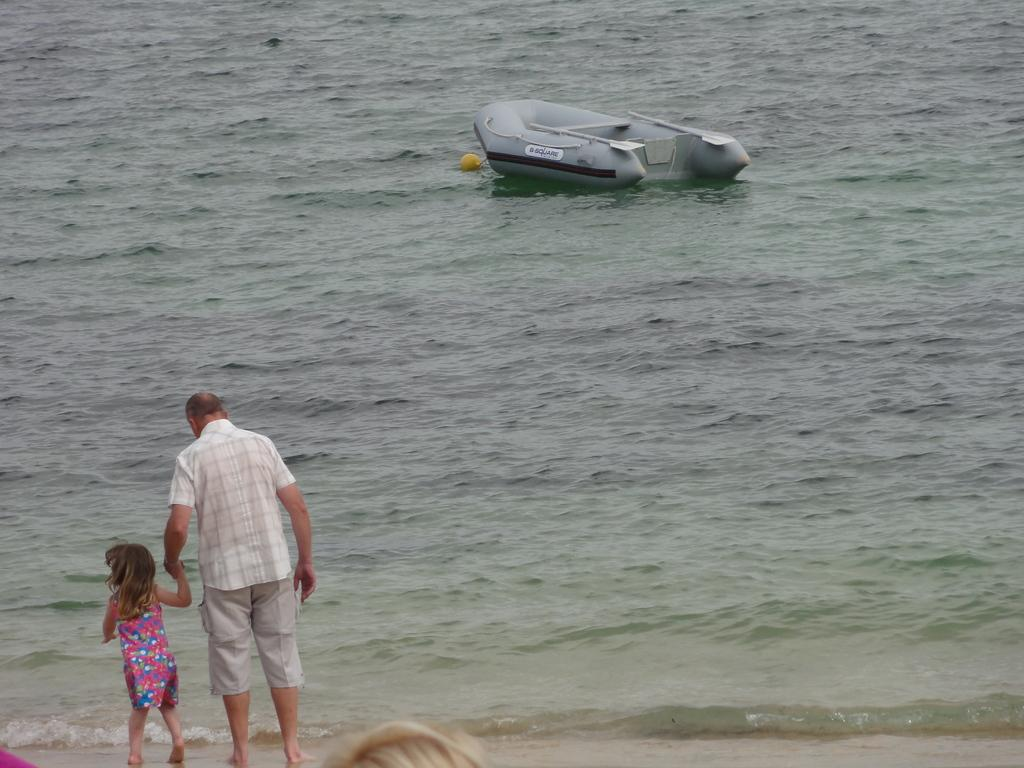How many people are in the image? There are two persons in the image. Where are the people located in the image? The people are standing on the seashore. What can be seen in the background of the image? There is an inflatable boat with paddles on the water in the background. What is the tendency of the cream in the image? There is no cream present in the image. How does the society depicted in the image function? The image does not depict a society, so it is not possible to determine how it functions. 